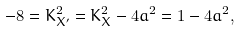Convert formula to latex. <formula><loc_0><loc_0><loc_500><loc_500>- 8 = K _ { X ^ { \prime } } ^ { 2 } = K _ { X } ^ { 2 } - 4 a ^ { 2 } = 1 - 4 a ^ { 2 } ,</formula> 